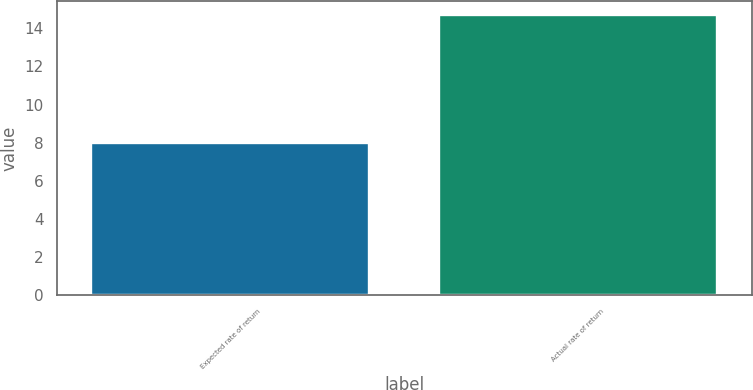Convert chart to OTSL. <chart><loc_0><loc_0><loc_500><loc_500><bar_chart><fcel>Expected rate of return<fcel>Actual rate of return<nl><fcel>8<fcel>14.7<nl></chart> 